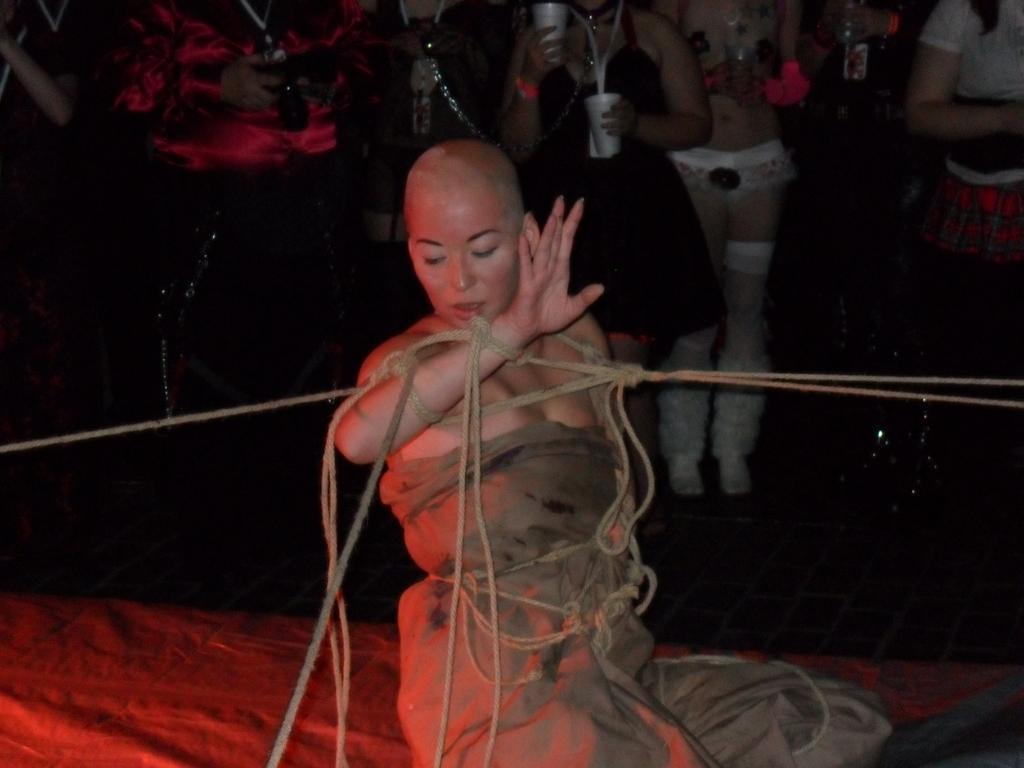Could you give a brief overview of what you see in this image? In this image there is a woman sitting on the floor. There are ropes around her. In the background there are people standing. The woman in the center is holding glasses in her hands. 